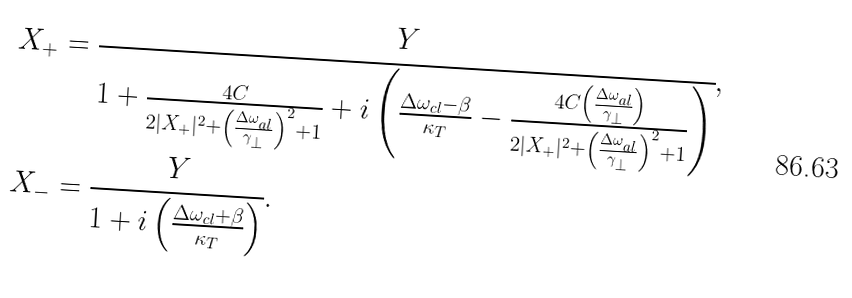<formula> <loc_0><loc_0><loc_500><loc_500>X _ { + } & = \cfrac { Y } { 1 + \frac { 4 C } { 2 | X _ { + } | ^ { 2 } + \left ( \frac { \Delta \omega _ { a l } } { \gamma _ { \perp } } \right ) ^ { 2 } + 1 } + i \left ( \frac { \Delta \omega _ { c l } - \beta } { \kappa _ { T } } - \frac { 4 C \left ( \frac { \Delta \omega _ { a l } } { \gamma _ { \perp } } \right ) } { 2 | X _ { + } | ^ { 2 } + \left ( \frac { \Delta \omega _ { a l } } { \gamma _ { \perp } } \right ) ^ { 2 } + 1 } \right ) } , \\ X _ { - } & = \cfrac { Y } { 1 + i \left ( \frac { \Delta \omega _ { c l } + \beta } { \kappa _ { T } } \right ) } .</formula> 